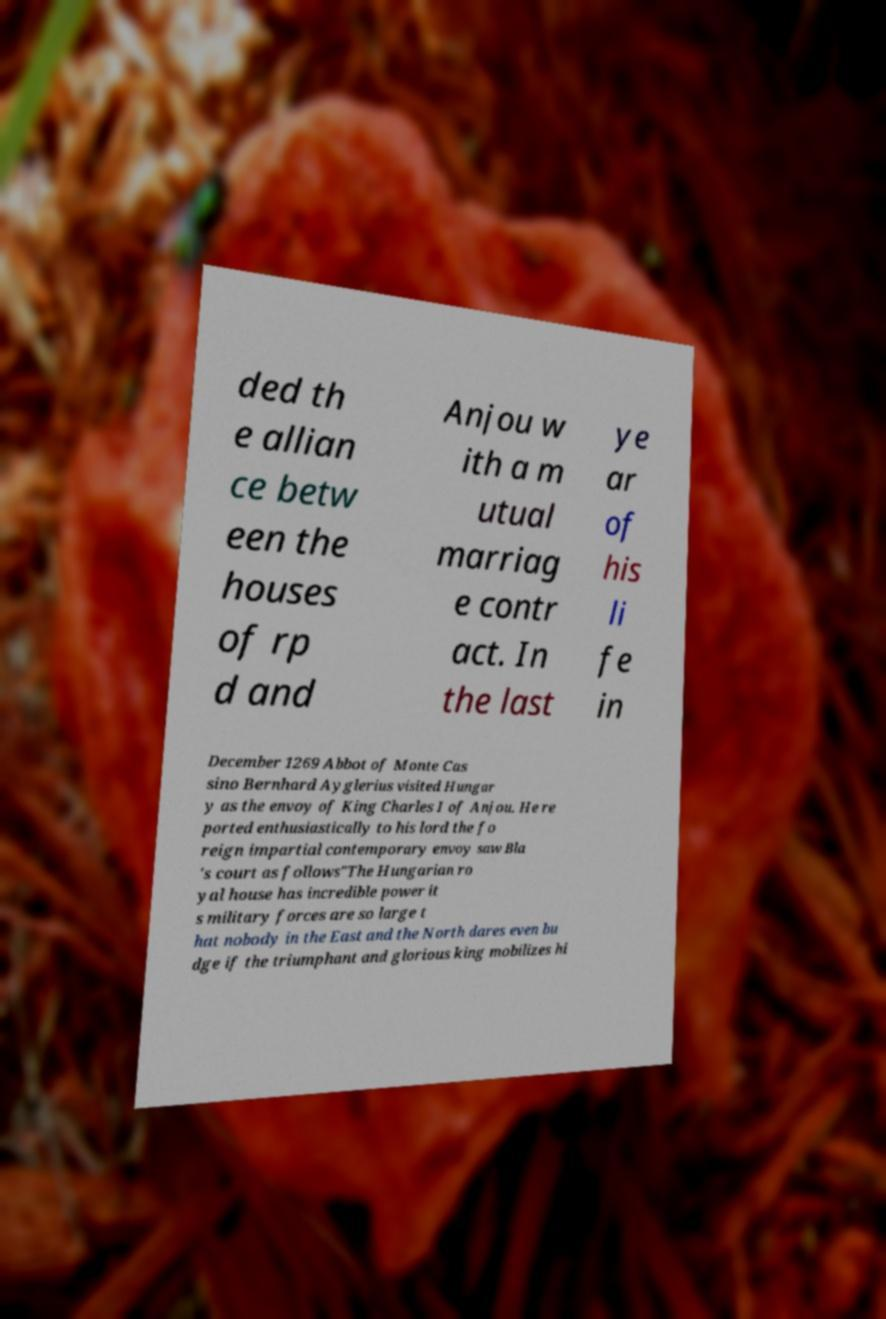There's text embedded in this image that I need extracted. Can you transcribe it verbatim? ded th e allian ce betw een the houses of rp d and Anjou w ith a m utual marriag e contr act. In the last ye ar of his li fe in December 1269 Abbot of Monte Cas sino Bernhard Ayglerius visited Hungar y as the envoy of King Charles I of Anjou. He re ported enthusiastically to his lord the fo reign impartial contemporary envoy saw Bla 's court as follows"The Hungarian ro yal house has incredible power it s military forces are so large t hat nobody in the East and the North dares even bu dge if the triumphant and glorious king mobilizes hi 